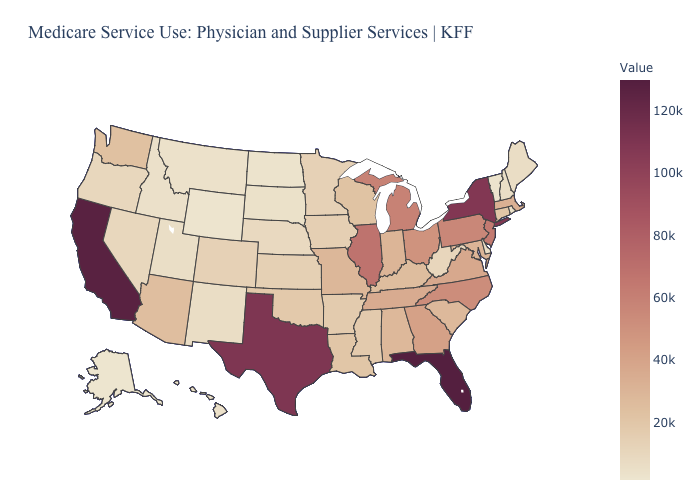Among the states that border Minnesota , which have the highest value?
Concise answer only. Wisconsin. Among the states that border Arkansas , which have the highest value?
Quick response, please. Texas. Among the states that border Texas , which have the lowest value?
Keep it brief. New Mexico. Is the legend a continuous bar?
Short answer required. Yes. Which states have the highest value in the USA?
Short answer required. Florida. Among the states that border New Hampshire , does Massachusetts have the lowest value?
Write a very short answer. No. 